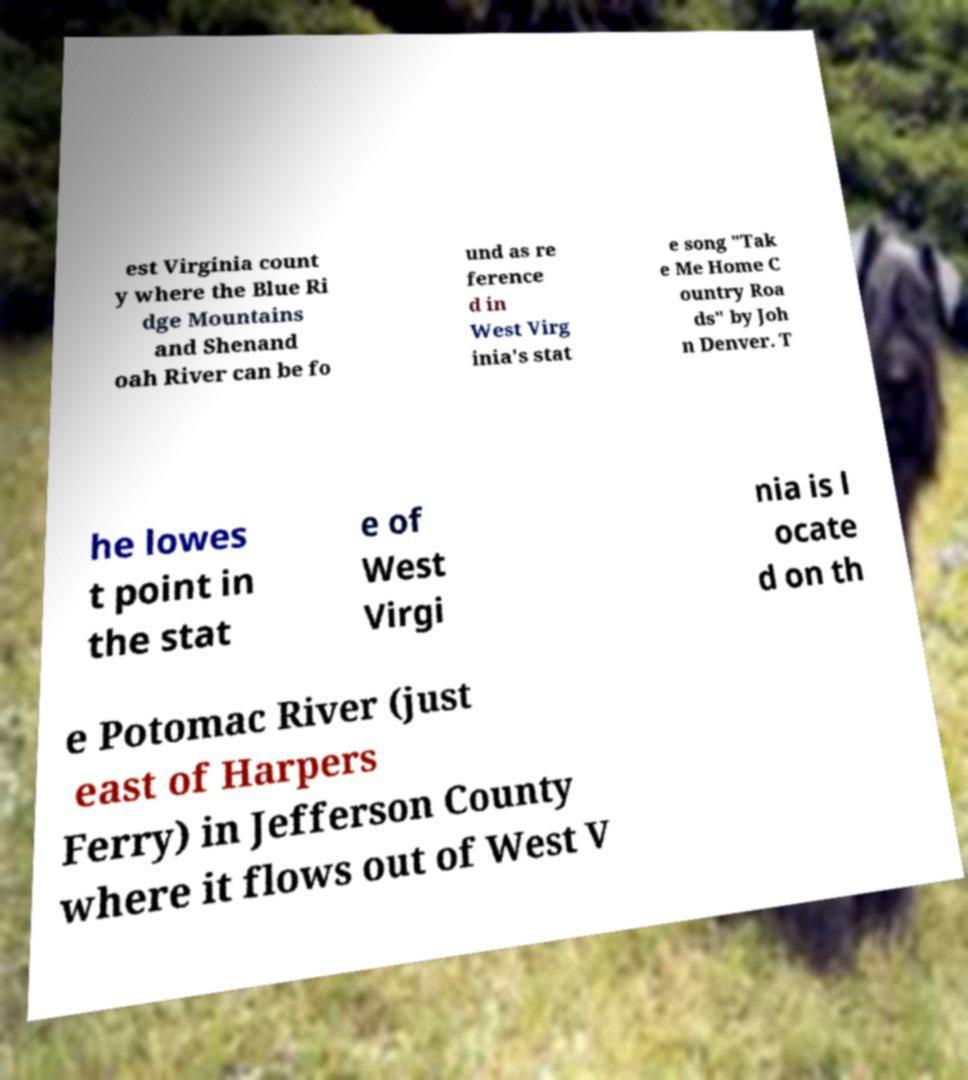I need the written content from this picture converted into text. Can you do that? est Virginia count y where the Blue Ri dge Mountains and Shenand oah River can be fo und as re ference d in West Virg inia's stat e song "Tak e Me Home C ountry Roa ds" by Joh n Denver. T he lowes t point in the stat e of West Virgi nia is l ocate d on th e Potomac River (just east of Harpers Ferry) in Jefferson County where it flows out of West V 